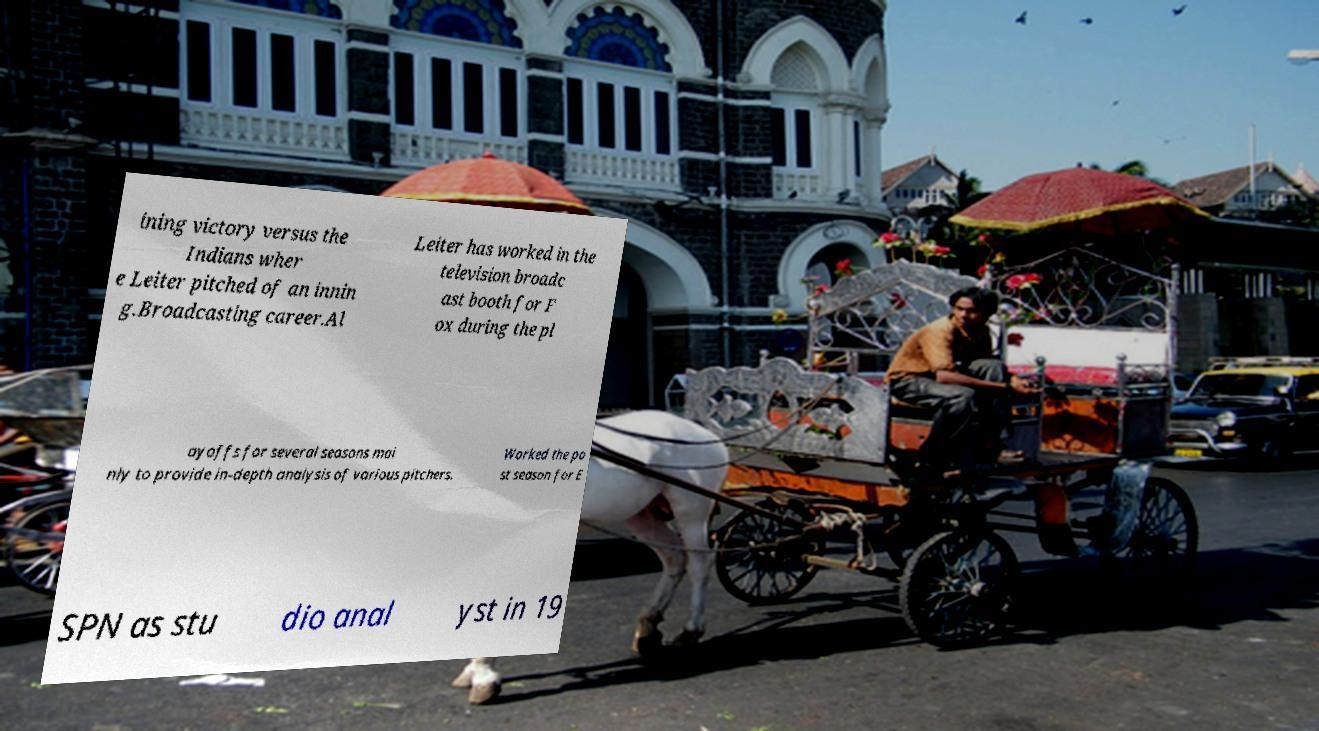There's text embedded in this image that I need extracted. Can you transcribe it verbatim? ining victory versus the Indians wher e Leiter pitched of an innin g.Broadcasting career.Al Leiter has worked in the television broadc ast booth for F ox during the pl ayoffs for several seasons mai nly to provide in-depth analysis of various pitchers. Worked the po st season for E SPN as stu dio anal yst in 19 